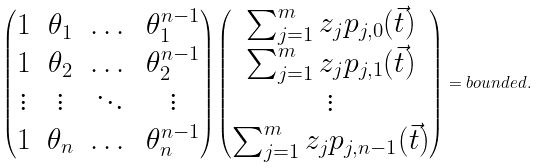<formula> <loc_0><loc_0><loc_500><loc_500>\begin{pmatrix} 1 & \theta _ { 1 } & \dots & \theta _ { 1 } ^ { n - 1 } \\ 1 & \theta _ { 2 } & \dots & \theta _ { 2 } ^ { n - 1 } \\ \vdots & \vdots & \ddots & \vdots \\ 1 & \theta _ { n } & \dots & \theta _ { n } ^ { n - 1 } \\ \end{pmatrix} \begin{pmatrix} \sum _ { j = 1 } ^ { m } z _ { j } p _ { j , 0 } ( \vec { t } ) \\ \sum _ { j = 1 } ^ { m } z _ { j } p _ { j , 1 } ( \vec { t } ) \\ \vdots \\ \sum _ { j = 1 } ^ { m } z _ { j } p _ { j , n - 1 } ( \vec { t } ) \\ \end{pmatrix} = b o u n d e d .</formula> 